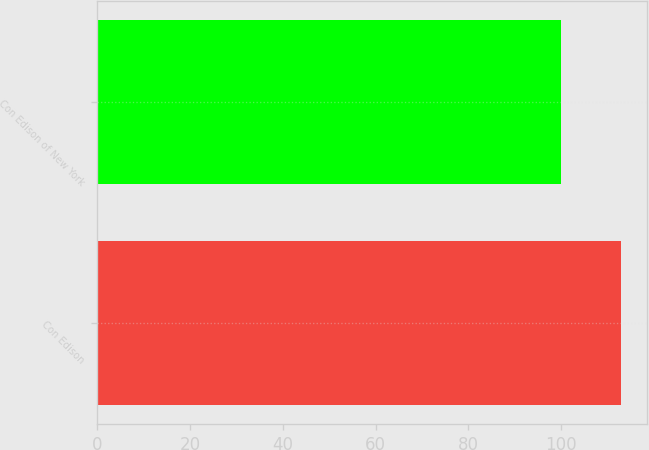<chart> <loc_0><loc_0><loc_500><loc_500><bar_chart><fcel>Con Edison<fcel>Con Edison of New York<nl><fcel>113<fcel>100<nl></chart> 